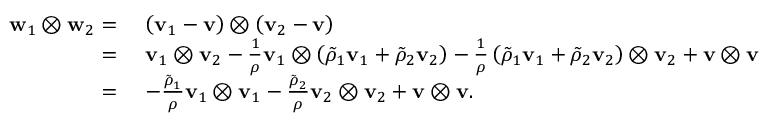Convert formula to latex. <formula><loc_0><loc_0><loc_500><loc_500>\begin{array} { r l } { w _ { 1 } \otimes w _ { 2 } = } & { \left ( v _ { 1 } - v \right ) \otimes \left ( v _ { 2 } - v \right ) } \\ { = } & { v _ { 1 } \otimes v _ { 2 } - \frac { 1 } { \rho } v _ { 1 } \otimes \left ( \tilde { \rho } _ { 1 } v _ { 1 } + \tilde { \rho } _ { 2 } v _ { 2 } \right ) - \frac { 1 } { \rho } \left ( \tilde { \rho } _ { 1 } v _ { 1 } + \tilde { \rho } _ { 2 } v _ { 2 } \right ) \otimes v _ { 2 } + v \otimes v } \\ { = } & { - \frac { \tilde { \rho } _ { 1 } } { \rho } v _ { 1 } \otimes v _ { 1 } - \frac { \tilde { \rho } _ { 2 } } { \rho } v _ { 2 } \otimes v _ { 2 } + v \otimes v . } \end{array}</formula> 